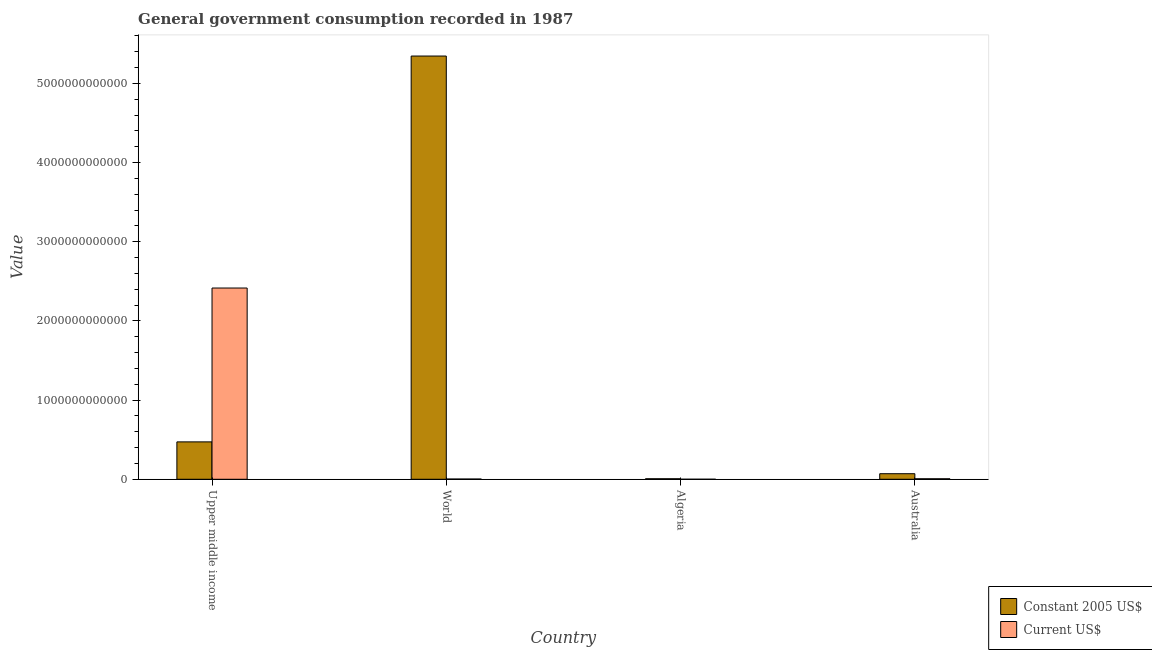How many different coloured bars are there?
Give a very brief answer. 2. How many groups of bars are there?
Keep it short and to the point. 4. Are the number of bars per tick equal to the number of legend labels?
Ensure brevity in your answer.  Yes. Are the number of bars on each tick of the X-axis equal?
Your answer should be very brief. Yes. How many bars are there on the 4th tick from the left?
Offer a very short reply. 2. What is the label of the 1st group of bars from the left?
Your answer should be compact. Upper middle income. What is the value consumed in current us$ in Algeria?
Give a very brief answer. 4.56e+08. Across all countries, what is the maximum value consumed in current us$?
Make the answer very short. 2.42e+12. Across all countries, what is the minimum value consumed in constant 2005 us$?
Give a very brief answer. 6.64e+09. In which country was the value consumed in current us$ maximum?
Offer a terse response. Upper middle income. In which country was the value consumed in current us$ minimum?
Ensure brevity in your answer.  Algeria. What is the total value consumed in current us$ in the graph?
Make the answer very short. 2.43e+12. What is the difference between the value consumed in current us$ in Upper middle income and that in World?
Give a very brief answer. 2.41e+12. What is the difference between the value consumed in constant 2005 us$ in Australia and the value consumed in current us$ in Upper middle income?
Keep it short and to the point. -2.34e+12. What is the average value consumed in constant 2005 us$ per country?
Give a very brief answer. 1.47e+12. What is the difference between the value consumed in current us$ and value consumed in constant 2005 us$ in World?
Keep it short and to the point. -5.34e+12. In how many countries, is the value consumed in constant 2005 us$ greater than 4800000000000 ?
Give a very brief answer. 1. What is the ratio of the value consumed in constant 2005 us$ in Algeria to that in World?
Keep it short and to the point. 0. Is the value consumed in current us$ in Algeria less than that in Australia?
Give a very brief answer. Yes. What is the difference between the highest and the second highest value consumed in constant 2005 us$?
Give a very brief answer. 4.87e+12. What is the difference between the highest and the lowest value consumed in constant 2005 us$?
Offer a very short reply. 5.34e+12. What does the 1st bar from the left in Algeria represents?
Offer a terse response. Constant 2005 US$. What does the 1st bar from the right in Australia represents?
Offer a terse response. Current US$. How many countries are there in the graph?
Ensure brevity in your answer.  4. What is the difference between two consecutive major ticks on the Y-axis?
Provide a short and direct response. 1.00e+12. Does the graph contain any zero values?
Your response must be concise. No. Does the graph contain grids?
Make the answer very short. No. Where does the legend appear in the graph?
Provide a short and direct response. Bottom right. How are the legend labels stacked?
Offer a very short reply. Vertical. What is the title of the graph?
Offer a terse response. General government consumption recorded in 1987. What is the label or title of the X-axis?
Give a very brief answer. Country. What is the label or title of the Y-axis?
Provide a succinct answer. Value. What is the Value in Constant 2005 US$ in Upper middle income?
Keep it short and to the point. 4.72e+11. What is the Value of Current US$ in Upper middle income?
Offer a very short reply. 2.42e+12. What is the Value of Constant 2005 US$ in World?
Your answer should be very brief. 5.34e+12. What is the Value of Current US$ in World?
Provide a succinct answer. 3.20e+09. What is the Value in Constant 2005 US$ in Algeria?
Give a very brief answer. 6.64e+09. What is the Value of Current US$ in Algeria?
Make the answer very short. 4.56e+08. What is the Value in Constant 2005 US$ in Australia?
Make the answer very short. 7.02e+1. What is the Value in Current US$ in Australia?
Keep it short and to the point. 6.45e+09. Across all countries, what is the maximum Value of Constant 2005 US$?
Your answer should be compact. 5.34e+12. Across all countries, what is the maximum Value of Current US$?
Make the answer very short. 2.42e+12. Across all countries, what is the minimum Value of Constant 2005 US$?
Give a very brief answer. 6.64e+09. Across all countries, what is the minimum Value of Current US$?
Ensure brevity in your answer.  4.56e+08. What is the total Value of Constant 2005 US$ in the graph?
Offer a very short reply. 5.89e+12. What is the total Value of Current US$ in the graph?
Make the answer very short. 2.43e+12. What is the difference between the Value in Constant 2005 US$ in Upper middle income and that in World?
Ensure brevity in your answer.  -4.87e+12. What is the difference between the Value of Current US$ in Upper middle income and that in World?
Provide a succinct answer. 2.41e+12. What is the difference between the Value in Constant 2005 US$ in Upper middle income and that in Algeria?
Give a very brief answer. 4.66e+11. What is the difference between the Value in Current US$ in Upper middle income and that in Algeria?
Ensure brevity in your answer.  2.41e+12. What is the difference between the Value of Constant 2005 US$ in Upper middle income and that in Australia?
Keep it short and to the point. 4.02e+11. What is the difference between the Value in Current US$ in Upper middle income and that in Australia?
Your answer should be compact. 2.41e+12. What is the difference between the Value of Constant 2005 US$ in World and that in Algeria?
Offer a terse response. 5.34e+12. What is the difference between the Value in Current US$ in World and that in Algeria?
Make the answer very short. 2.74e+09. What is the difference between the Value of Constant 2005 US$ in World and that in Australia?
Provide a succinct answer. 5.27e+12. What is the difference between the Value of Current US$ in World and that in Australia?
Offer a very short reply. -3.25e+09. What is the difference between the Value of Constant 2005 US$ in Algeria and that in Australia?
Your answer should be compact. -6.36e+1. What is the difference between the Value in Current US$ in Algeria and that in Australia?
Offer a very short reply. -5.99e+09. What is the difference between the Value of Constant 2005 US$ in Upper middle income and the Value of Current US$ in World?
Provide a short and direct response. 4.69e+11. What is the difference between the Value of Constant 2005 US$ in Upper middle income and the Value of Current US$ in Algeria?
Your response must be concise. 4.72e+11. What is the difference between the Value of Constant 2005 US$ in Upper middle income and the Value of Current US$ in Australia?
Offer a terse response. 4.66e+11. What is the difference between the Value in Constant 2005 US$ in World and the Value in Current US$ in Algeria?
Your response must be concise. 5.34e+12. What is the difference between the Value of Constant 2005 US$ in World and the Value of Current US$ in Australia?
Ensure brevity in your answer.  5.34e+12. What is the difference between the Value in Constant 2005 US$ in Algeria and the Value in Current US$ in Australia?
Your answer should be very brief. 1.97e+08. What is the average Value of Constant 2005 US$ per country?
Your answer should be very brief. 1.47e+12. What is the average Value of Current US$ per country?
Give a very brief answer. 6.06e+11. What is the difference between the Value in Constant 2005 US$ and Value in Current US$ in Upper middle income?
Offer a terse response. -1.94e+12. What is the difference between the Value in Constant 2005 US$ and Value in Current US$ in World?
Give a very brief answer. 5.34e+12. What is the difference between the Value of Constant 2005 US$ and Value of Current US$ in Algeria?
Give a very brief answer. 6.19e+09. What is the difference between the Value in Constant 2005 US$ and Value in Current US$ in Australia?
Provide a succinct answer. 6.38e+1. What is the ratio of the Value of Constant 2005 US$ in Upper middle income to that in World?
Your response must be concise. 0.09. What is the ratio of the Value in Current US$ in Upper middle income to that in World?
Offer a terse response. 755.22. What is the ratio of the Value in Constant 2005 US$ in Upper middle income to that in Algeria?
Your answer should be compact. 71.09. What is the ratio of the Value in Current US$ in Upper middle income to that in Algeria?
Provide a succinct answer. 5290.64. What is the ratio of the Value in Constant 2005 US$ in Upper middle income to that in Australia?
Offer a very short reply. 6.73. What is the ratio of the Value in Current US$ in Upper middle income to that in Australia?
Offer a very short reply. 374.72. What is the ratio of the Value of Constant 2005 US$ in World to that in Algeria?
Give a very brief answer. 804.67. What is the ratio of the Value in Current US$ in World to that in Algeria?
Ensure brevity in your answer.  7.01. What is the ratio of the Value of Constant 2005 US$ in World to that in Australia?
Your response must be concise. 76.13. What is the ratio of the Value of Current US$ in World to that in Australia?
Ensure brevity in your answer.  0.5. What is the ratio of the Value in Constant 2005 US$ in Algeria to that in Australia?
Offer a very short reply. 0.09. What is the ratio of the Value in Current US$ in Algeria to that in Australia?
Your answer should be compact. 0.07. What is the difference between the highest and the second highest Value of Constant 2005 US$?
Provide a short and direct response. 4.87e+12. What is the difference between the highest and the second highest Value of Current US$?
Your answer should be very brief. 2.41e+12. What is the difference between the highest and the lowest Value in Constant 2005 US$?
Your answer should be compact. 5.34e+12. What is the difference between the highest and the lowest Value of Current US$?
Provide a succinct answer. 2.41e+12. 